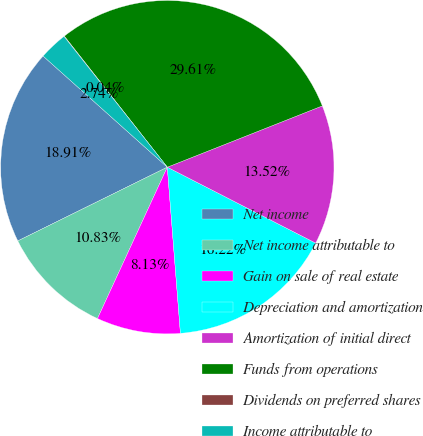Convert chart to OTSL. <chart><loc_0><loc_0><loc_500><loc_500><pie_chart><fcel>Net income<fcel>Net income attributable to<fcel>Gain on sale of real estate<fcel>Depreciation and amortization<fcel>Amortization of initial direct<fcel>Funds from operations<fcel>Dividends on preferred shares<fcel>Income attributable to<nl><fcel>18.91%<fcel>10.83%<fcel>8.13%<fcel>16.22%<fcel>13.52%<fcel>29.61%<fcel>0.04%<fcel>2.74%<nl></chart> 